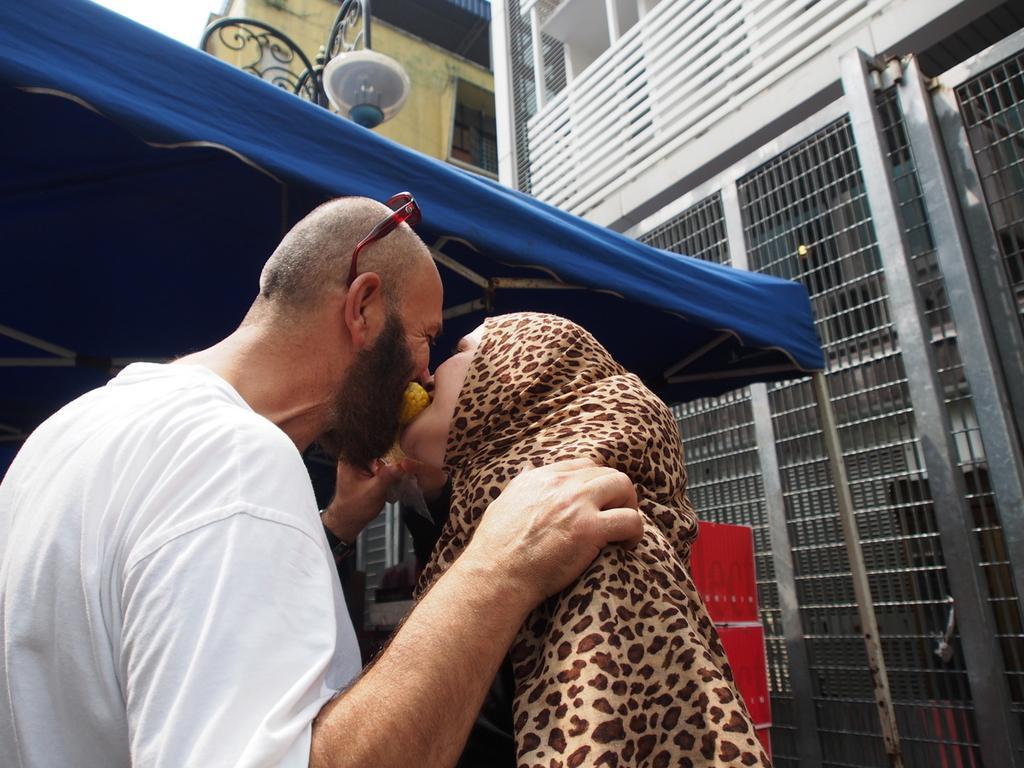Can you describe this image briefly? In this picture there is a man and woman standing and eating. At the back there is a building and there is a tent and there is a street light and there is an object. At the top there is sky. 